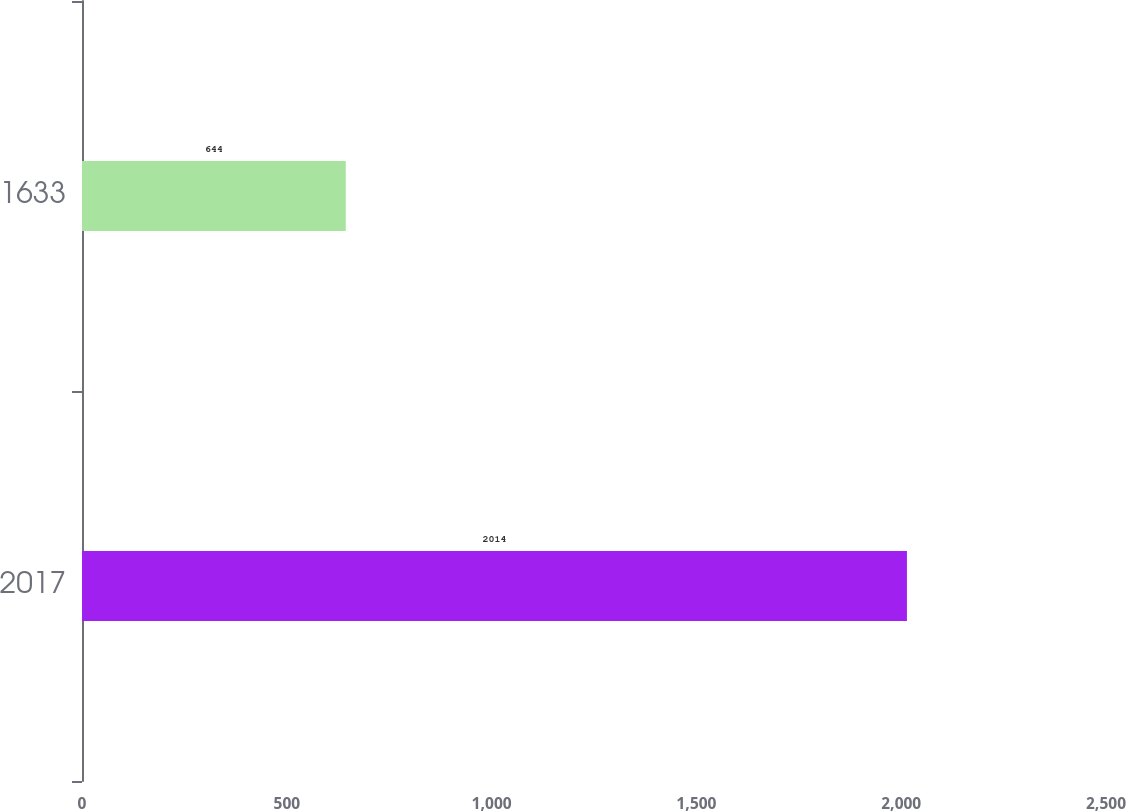<chart> <loc_0><loc_0><loc_500><loc_500><bar_chart><fcel>2017<fcel>1633<nl><fcel>2014<fcel>644<nl></chart> 